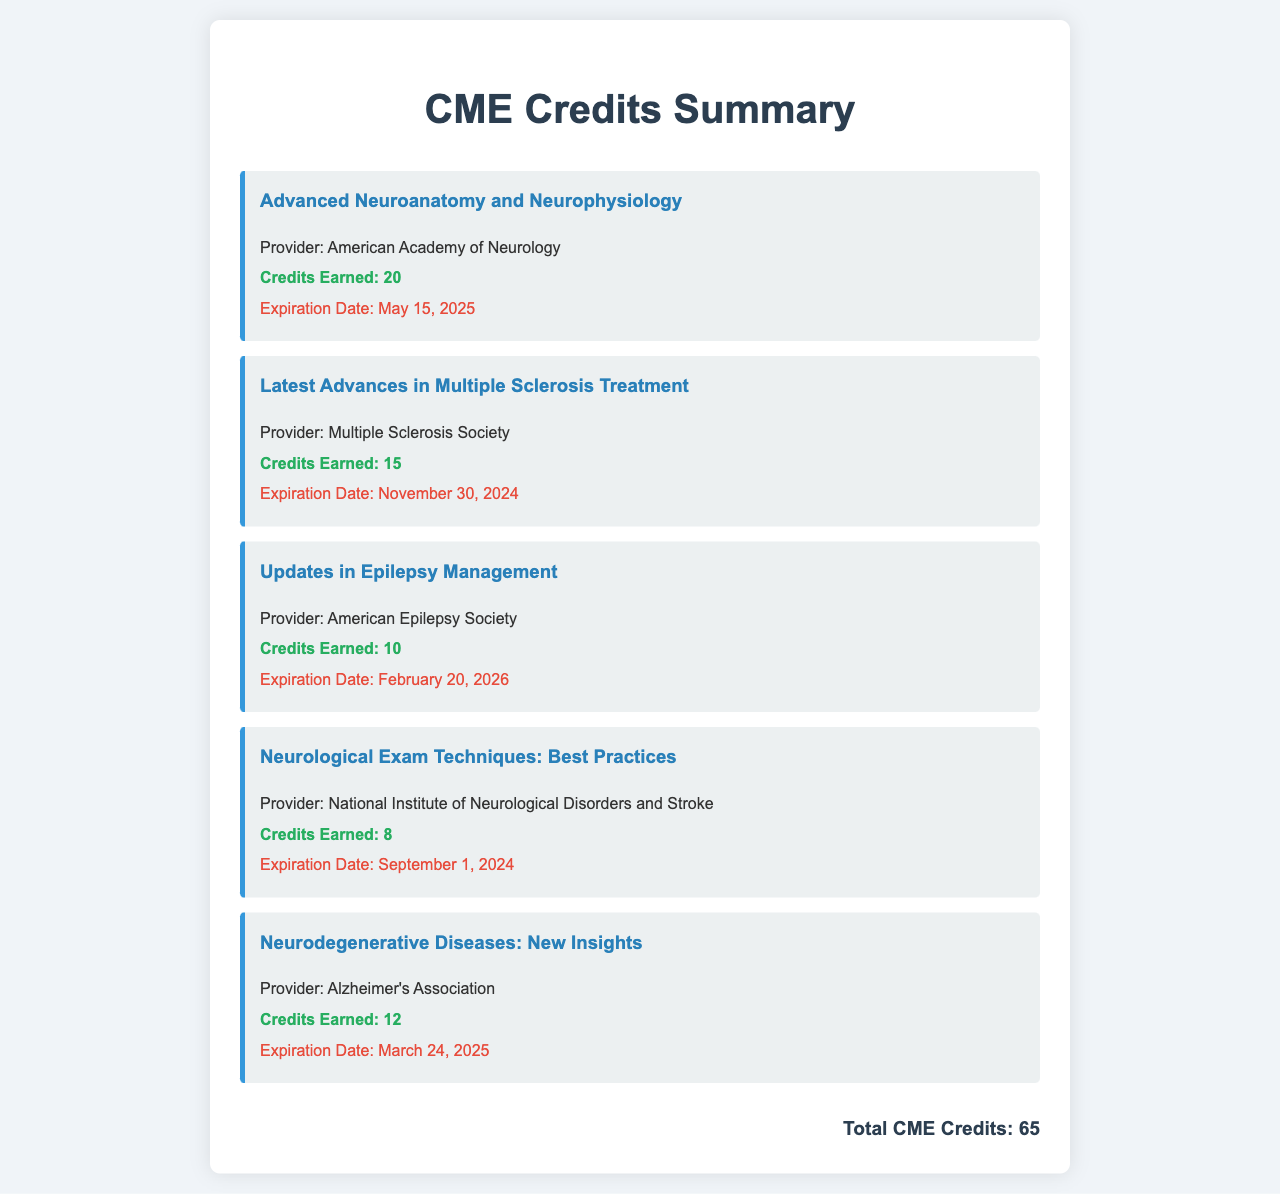What is the total number of CME credits earned? The total number of CME credits is indicated at the bottom of the document, summarizing all credits earned across various courses.
Answer: 65 When does the CME credits for "Latest Advances in Multiple Sclerosis Treatment" expire? The expiration date for this course is stated in the document as part of the detailed information for this course.
Answer: November 30, 2024 Which provider is associated with "Advanced Neuroanatomy and Neurophysiology"? The provider for this course is explicitly mentioned under its title in the document.
Answer: American Academy of Neurology How many credits were earned for "Neurological Exam Techniques: Best Practices"? The credits earned for this specific course are listed directly in the document alongside the course title.
Answer: 8 What is the expiration date for the "Updates in Epilepsy Management" course? The expiration date is provided in the course details section of the document.
Answer: February 20, 2026 Which course provides the highest number of credits? Comparing the credits for all listed courses will reveal which course offers the most; this involves simple comparison.
Answer: Advanced Neuroanatomy and Neurophysiology What is the provider for the course related to neurodegenerative diseases? The provider is clearly stated in the course description within the document.
Answer: Alzheimer's Association What are the credits earned for "Neurodegenerative Diseases: New Insights"? This information is provided in the course description section, detailing the credits earned.
Answer: 12 